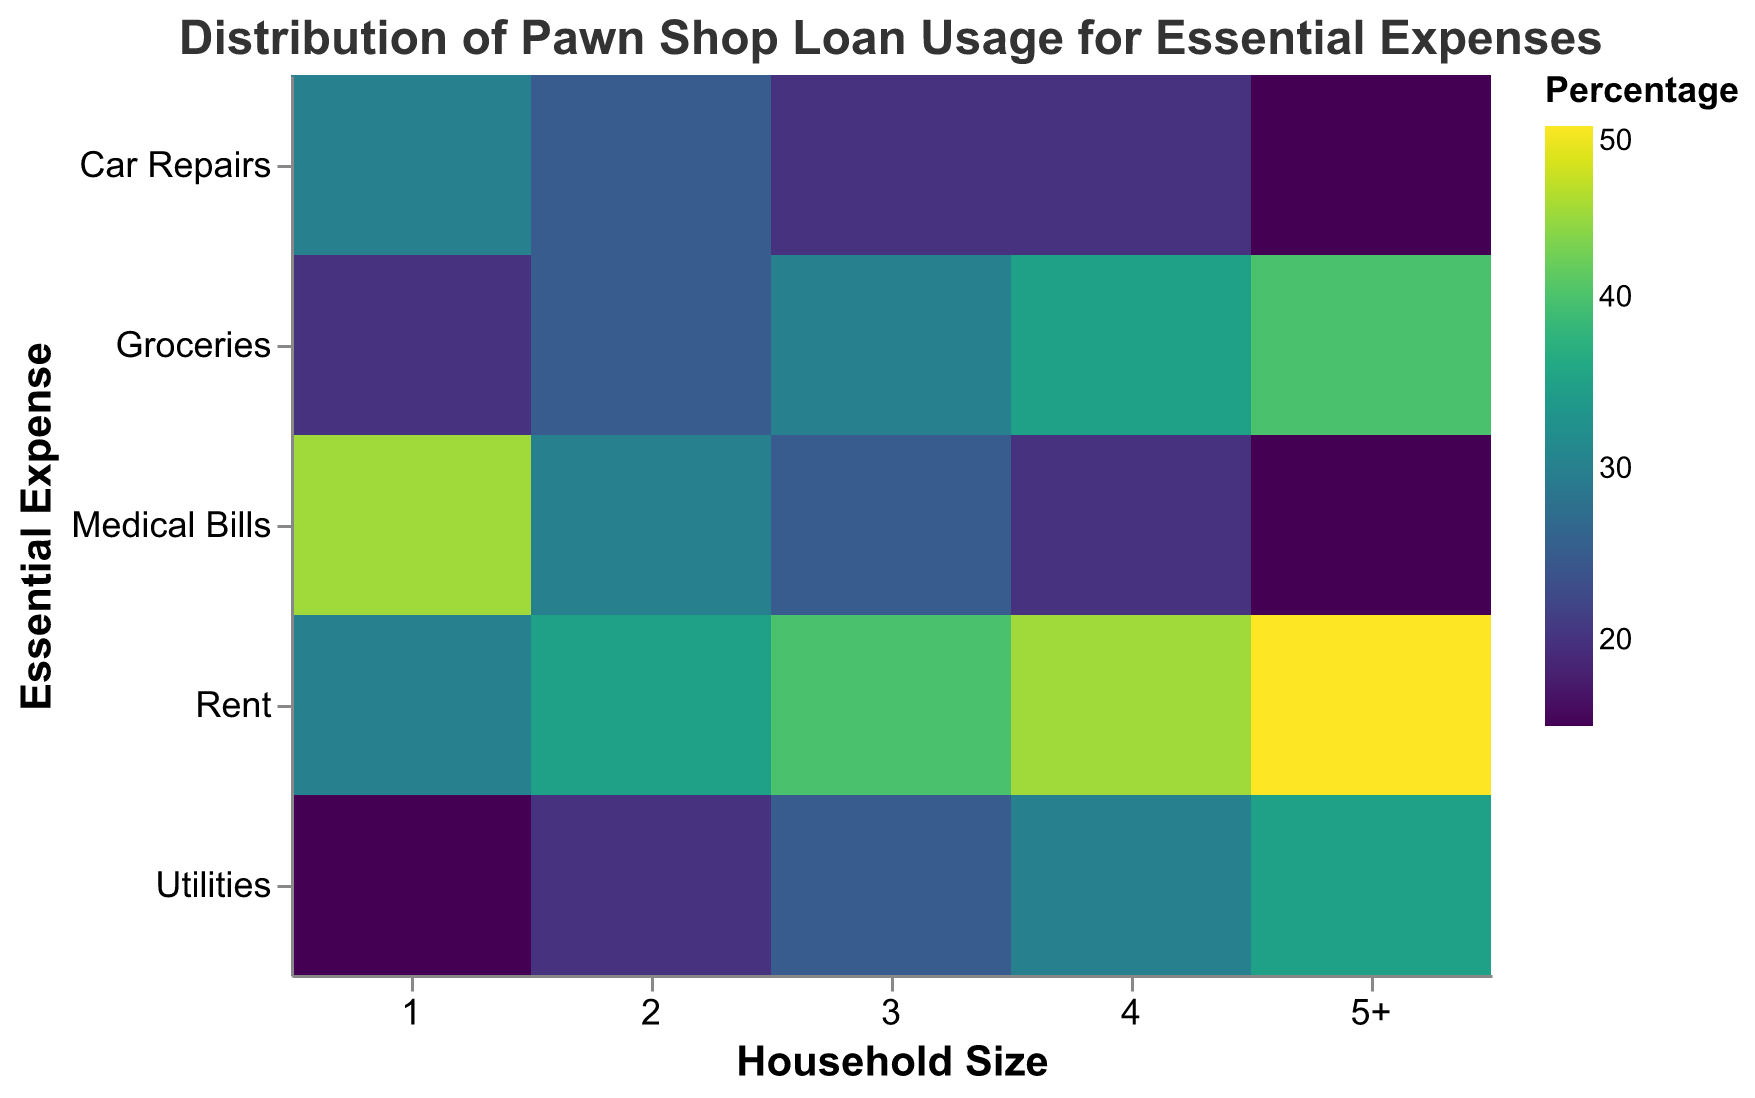What is the title of the heatmap? The title is usually displayed at the top of the visualization, summarizing the purpose or content of the chart.
Answer: Distribution of Pawn Shop Loan Usage for Essential Expenses What household size has the highest loan usage for rent? By looking at the heatmap, you can identify the household size with the darkest color (indicative of the highest value) in the "Rent" row.
Answer: 5+ Which essential expense does a household of size 1 mostly use pawn shop loans for? Locate the "Household Size: 1" column and find the cell with the darkest color, which represents the highest percentage within that column.
Answer: Medical Bills How does the loan usage for medical bills change as household size increases? Compare the cells in the "Medical Bills" row across different household sizes from 1 to 5+. Observe the trend in colors.
Answer: It decreases For a household size of 3, which essential expense is the least covered by pawn shop loans? In the "Household Size: 3" column, identify the cell with the lightest color, which indicates the lowest percentage within that column.
Answer: Car Repairs What is the average loan usage percentage for utilities across all household sizes? Find the values for "Utilities" across all household sizes and compute the average (15 + 20 + 25 + 30 + 35) / 5.
Answer: 25% Which essential expense shows the most uniform loan usage distribution across all household sizes? Look for the row where the color differences between the cells are minimal, indicating relatively uniform usage across household sizes.
Answer: Groceries How much higher is the loan usage for groceries in a 5+ household compared to a household of size 2? Subtract the loan usage percentage for groceries in household size 2 (25) from that in household size 5+ (40).
Answer: 15% What household size uses the most pawn shop loans for car repairs? Compare the values across the "Car Repairs" row and find the column with the highest value.
Answer: 1 Which household size demonstrates the most balanced loan usage distribution across all essential expenses? Identify the column where the colors are the most similar in intensity, indicating a more balanced loan usage across the different essential expenses.
Answer: 2 